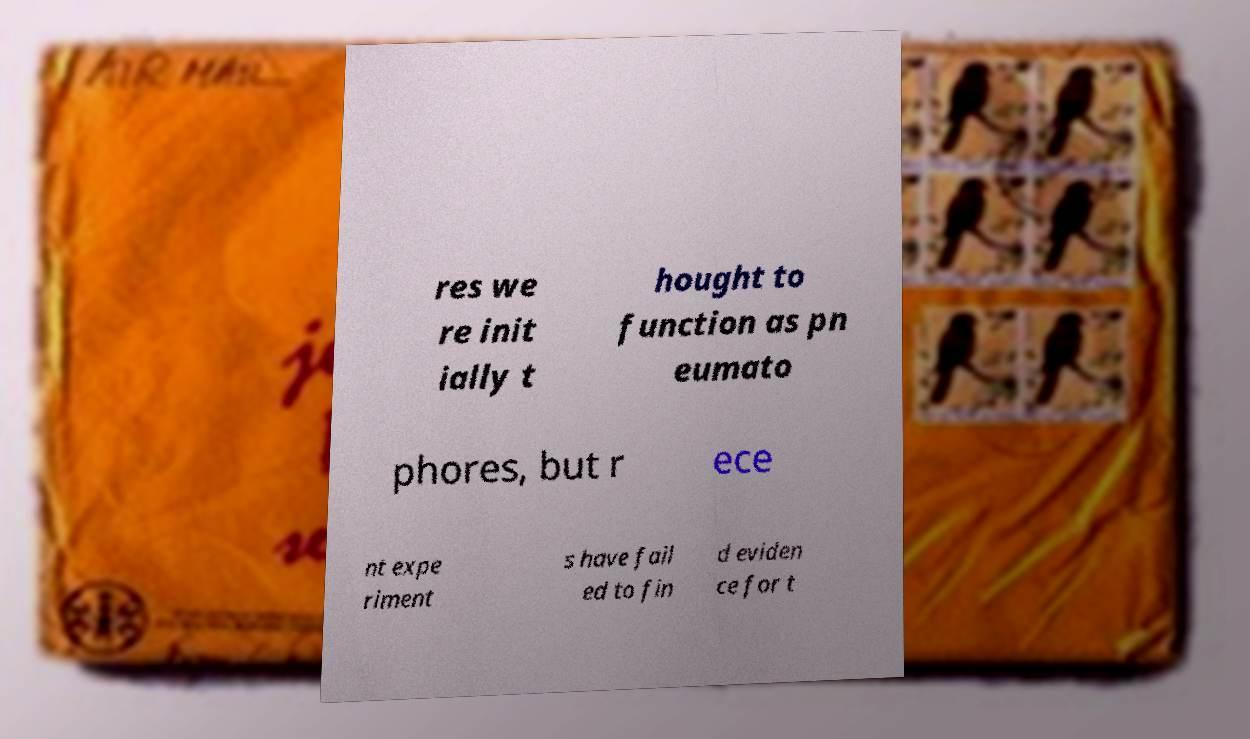I need the written content from this picture converted into text. Can you do that? res we re init ially t hought to function as pn eumato phores, but r ece nt expe riment s have fail ed to fin d eviden ce for t 